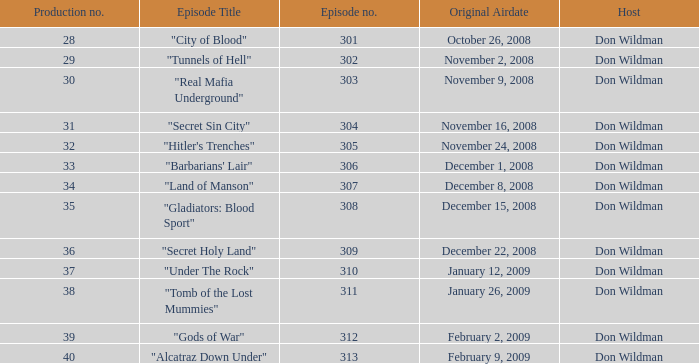What is the episode number of the episode that originally aired on January 26, 2009 and had a production number smaller than 38? 0.0. 